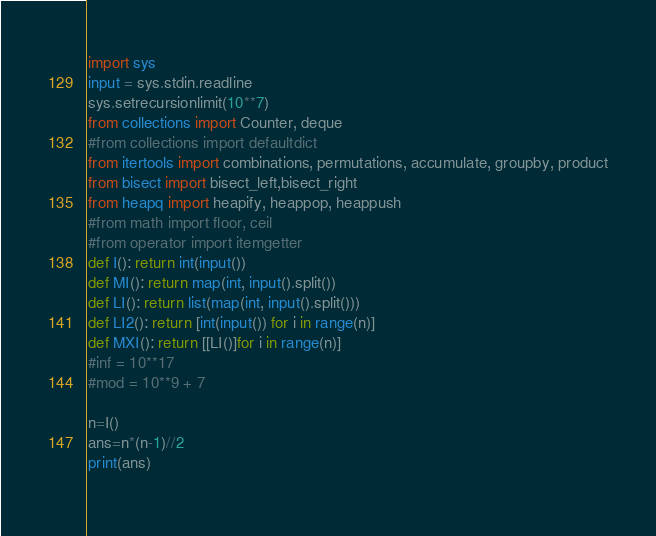Convert code to text. <code><loc_0><loc_0><loc_500><loc_500><_Python_>import sys
input = sys.stdin.readline
sys.setrecursionlimit(10**7)
from collections import Counter, deque
#from collections import defaultdict
from itertools import combinations, permutations, accumulate, groupby, product
from bisect import bisect_left,bisect_right
from heapq import heapify, heappop, heappush
#from math import floor, ceil
#from operator import itemgetter
def I(): return int(input())
def MI(): return map(int, input().split())
def LI(): return list(map(int, input().split()))
def LI2(): return [int(input()) for i in range(n)]
def MXI(): return [[LI()]for i in range(n)]
#inf = 10**17
#mod = 10**9 + 7

n=I()
ans=n*(n-1)//2
print(ans)
    </code> 